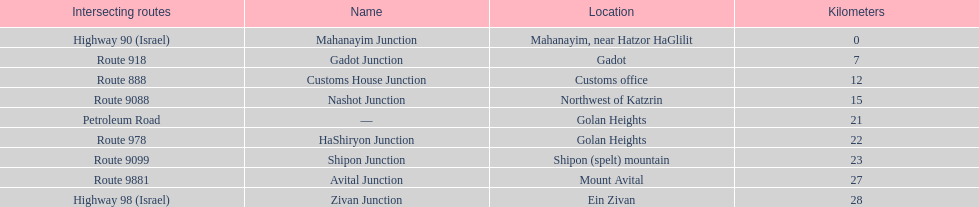What is the last junction on highway 91? Zivan Junction. 